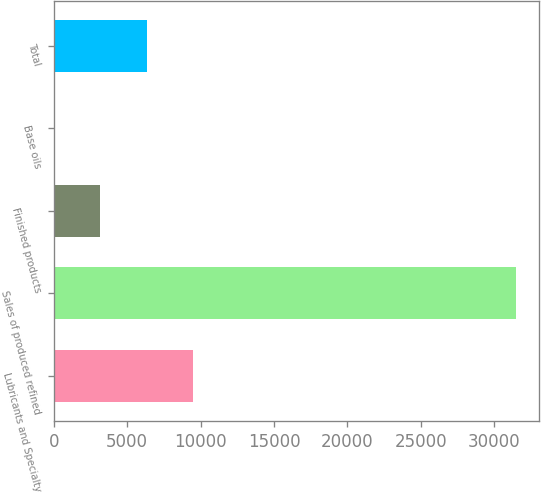<chart> <loc_0><loc_0><loc_500><loc_500><bar_chart><fcel>Lubricants and Specialty<fcel>Sales of produced refined<fcel>Finished products<fcel>Base oils<fcel>Total<nl><fcel>9465.7<fcel>31480<fcel>3175.9<fcel>31<fcel>6320.8<nl></chart> 